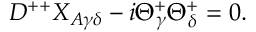Convert formula to latex. <formula><loc_0><loc_0><loc_500><loc_500>D ^ { + + } X _ { A \gamma \delta } - i \Theta _ { \gamma } ^ { + } \Theta _ { \delta } ^ { + } = 0 .</formula> 